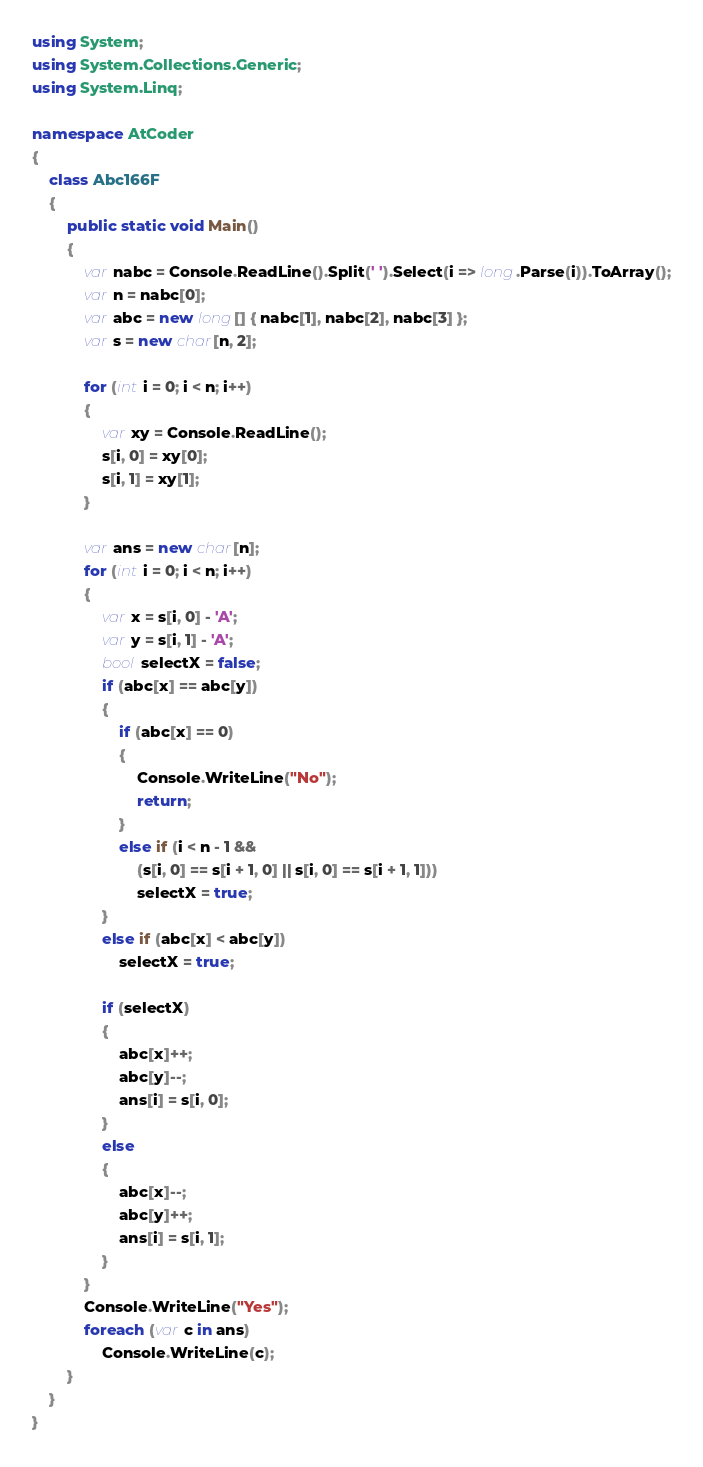Convert code to text. <code><loc_0><loc_0><loc_500><loc_500><_C#_>using System;
using System.Collections.Generic;
using System.Linq;

namespace AtCoder
{
    class Abc166F
    {
        public static void Main()
        {
            var nabc = Console.ReadLine().Split(' ').Select(i => long.Parse(i)).ToArray();
            var n = nabc[0];
            var abc = new long[] { nabc[1], nabc[2], nabc[3] };
            var s = new char[n, 2];

            for (int i = 0; i < n; i++)
            {
                var xy = Console.ReadLine();
                s[i, 0] = xy[0];
                s[i, 1] = xy[1];
            }

            var ans = new char[n];
            for (int i = 0; i < n; i++)
            {
                var x = s[i, 0] - 'A';
                var y = s[i, 1] - 'A';
                bool selectX = false;
                if (abc[x] == abc[y])
                {
                    if (abc[x] == 0)
                    {
                        Console.WriteLine("No");
                        return;
                    }
                    else if (i < n - 1 &&
                        (s[i, 0] == s[i + 1, 0] || s[i, 0] == s[i + 1, 1]))
                        selectX = true;
                }
                else if (abc[x] < abc[y])
                    selectX = true;

                if (selectX)
                {
                    abc[x]++;
                    abc[y]--;
                    ans[i] = s[i, 0];
                }
                else
                {
                    abc[x]--;
                    abc[y]++;
                    ans[i] = s[i, 1];
                }
            }
            Console.WriteLine("Yes");
            foreach (var c in ans)
                Console.WriteLine(c);
        }
    }
}
</code> 